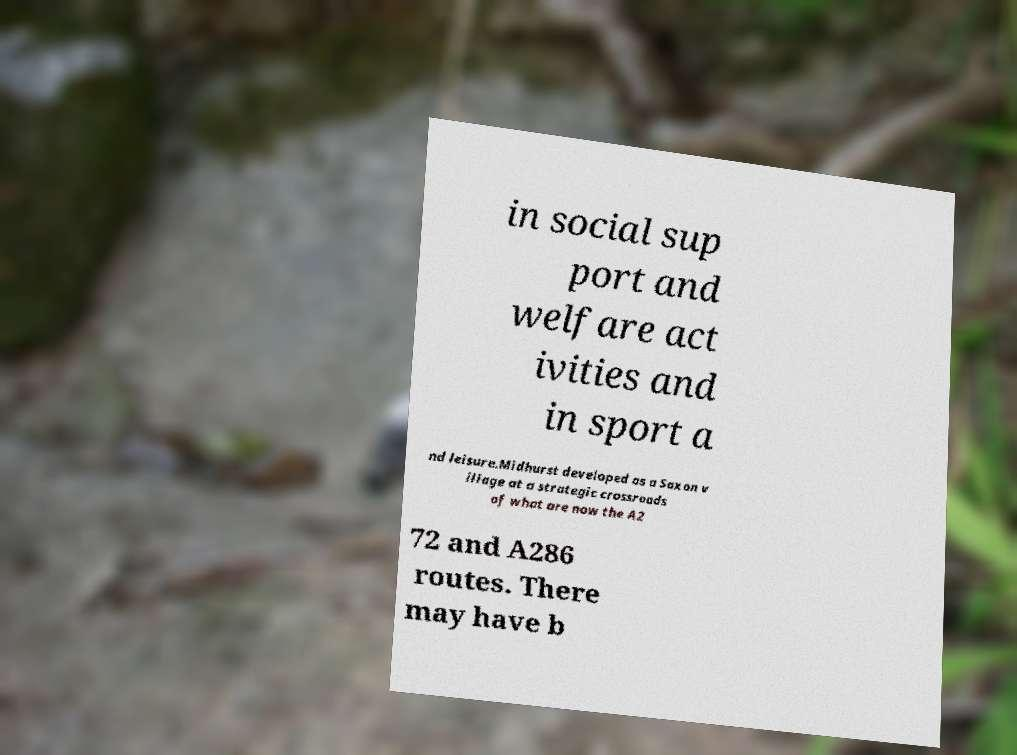Could you extract and type out the text from this image? in social sup port and welfare act ivities and in sport a nd leisure.Midhurst developed as a Saxon v illage at a strategic crossroads of what are now the A2 72 and A286 routes. There may have b 